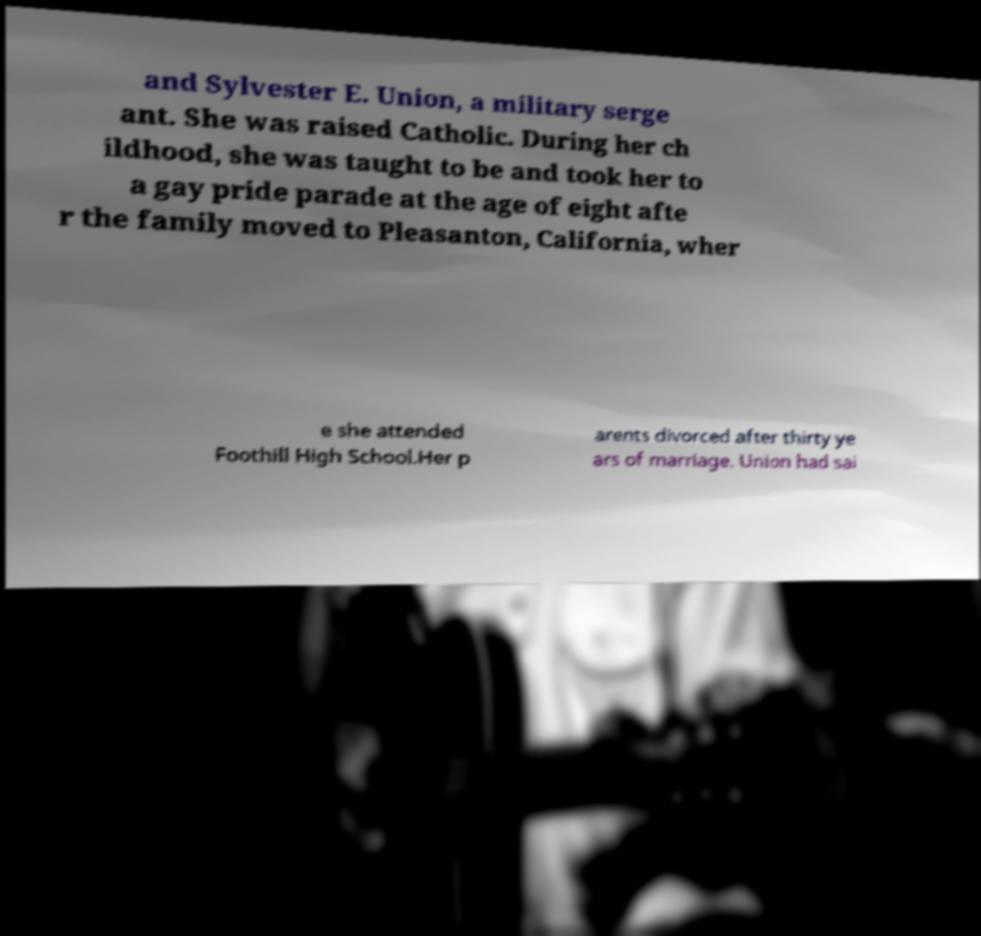What messages or text are displayed in this image? I need them in a readable, typed format. and Sylvester E. Union, a military serge ant. She was raised Catholic. During her ch ildhood, she was taught to be and took her to a gay pride parade at the age of eight afte r the family moved to Pleasanton, California, wher e she attended Foothill High School.Her p arents divorced after thirty ye ars of marriage. Union had sai 